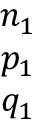Convert formula to latex. <formula><loc_0><loc_0><loc_500><loc_500>\begin{array} { c } { n _ { 1 } } \\ { p _ { 1 } } \\ { q _ { 1 } } \end{array}</formula> 